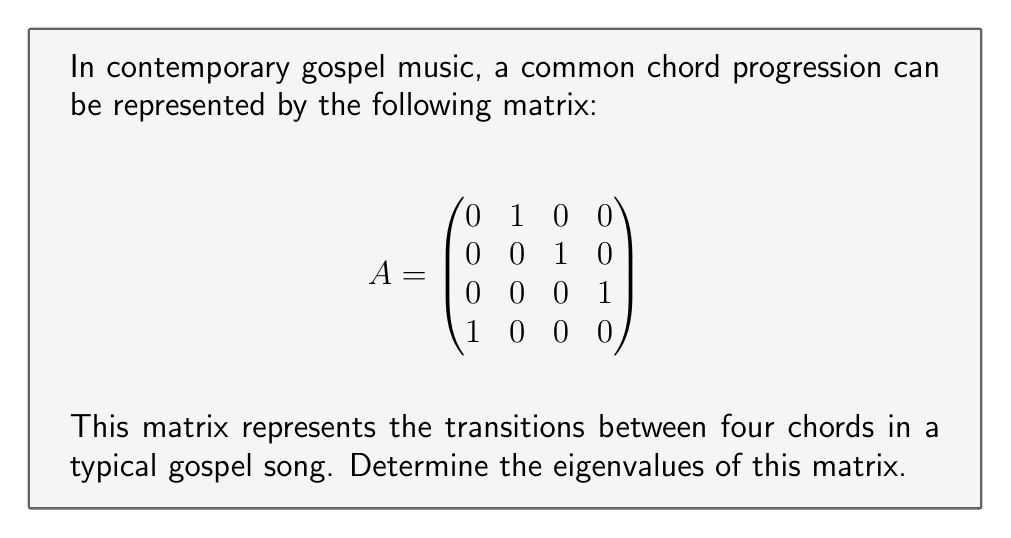Solve this math problem. To find the eigenvalues of matrix A, we need to solve the characteristic equation:

$$\det(A - \lambda I) = 0$$

where $\lambda$ represents the eigenvalues and $I$ is the 4x4 identity matrix.

Step 1: Set up the characteristic equation
$$\det\begin{pmatrix}
-\lambda & 1 & 0 & 0 \\
0 & -\lambda & 1 & 0 \\
0 & 0 & -\lambda & 1 \\
1 & 0 & 0 & -\lambda
\end{pmatrix} = 0$$

Step 2: Calculate the determinant
Expanding along the first row:
$$(-\lambda)(-\lambda)(-\lambda)(-\lambda) - 1 = 0$$

Step 3: Simplify the equation
$$\lambda^4 - 1 = 0$$

Step 4: Solve for $\lambda$
$$\lambda^4 = 1$$
$$\lambda = \sqrt[4]{1} = \pm 1, \pm i$$

Therefore, the eigenvalues are:
$$\lambda_1 = 1, \lambda_2 = -1, \lambda_3 = i, \lambda_4 = -i$$

These eigenvalues represent the harmonic structure of the chord progression, with the real eigenvalues indicating stable harmonies and the imaginary eigenvalues suggesting cyclical patterns in the music.
Answer: $\lambda = 1, -1, i, -i$ 